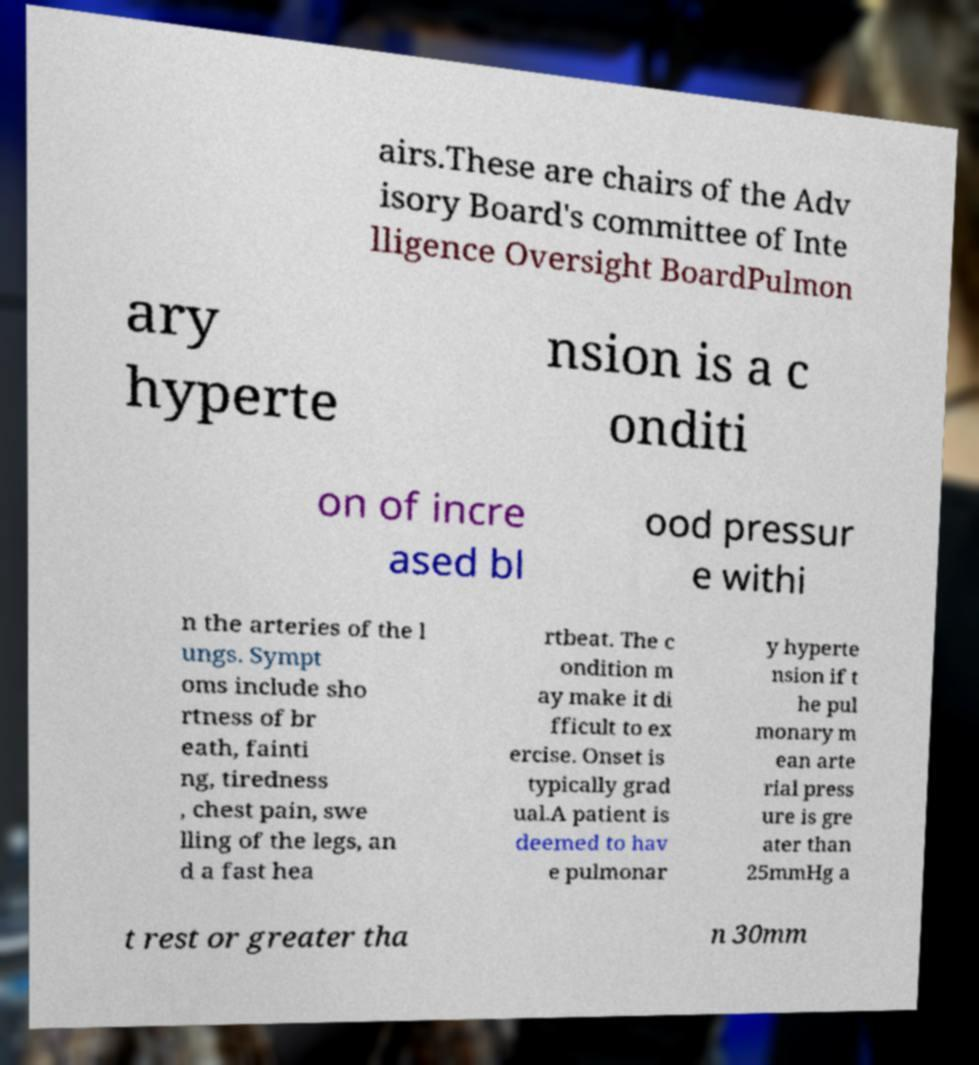Can you accurately transcribe the text from the provided image for me? airs.These are chairs of the Adv isory Board's committee of Inte lligence Oversight BoardPulmon ary hyperte nsion is a c onditi on of incre ased bl ood pressur e withi n the arteries of the l ungs. Sympt oms include sho rtness of br eath, fainti ng, tiredness , chest pain, swe lling of the legs, an d a fast hea rtbeat. The c ondition m ay make it di fficult to ex ercise. Onset is typically grad ual.A patient is deemed to hav e pulmonar y hyperte nsion if t he pul monary m ean arte rial press ure is gre ater than 25mmHg a t rest or greater tha n 30mm 